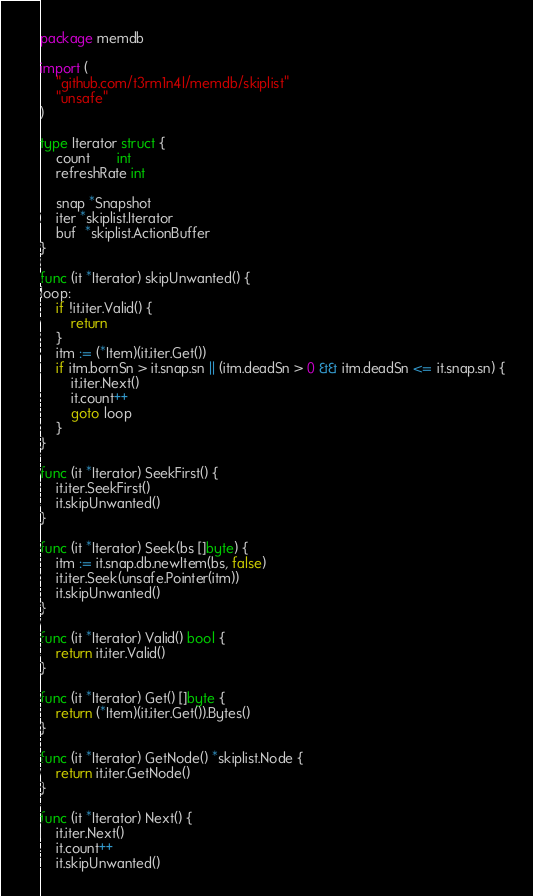<code> <loc_0><loc_0><loc_500><loc_500><_Go_>package memdb

import (
	"github.com/t3rm1n4l/memdb/skiplist"
	"unsafe"
)

type Iterator struct {
	count       int
	refreshRate int

	snap *Snapshot
	iter *skiplist.Iterator
	buf  *skiplist.ActionBuffer
}

func (it *Iterator) skipUnwanted() {
loop:
	if !it.iter.Valid() {
		return
	}
	itm := (*Item)(it.iter.Get())
	if itm.bornSn > it.snap.sn || (itm.deadSn > 0 && itm.deadSn <= it.snap.sn) {
		it.iter.Next()
		it.count++
		goto loop
	}
}

func (it *Iterator) SeekFirst() {
	it.iter.SeekFirst()
	it.skipUnwanted()
}

func (it *Iterator) Seek(bs []byte) {
	itm := it.snap.db.newItem(bs, false)
	it.iter.Seek(unsafe.Pointer(itm))
	it.skipUnwanted()
}

func (it *Iterator) Valid() bool {
	return it.iter.Valid()
}

func (it *Iterator) Get() []byte {
	return (*Item)(it.iter.Get()).Bytes()
}

func (it *Iterator) GetNode() *skiplist.Node {
	return it.iter.GetNode()
}

func (it *Iterator) Next() {
	it.iter.Next()
	it.count++
	it.skipUnwanted()</code> 